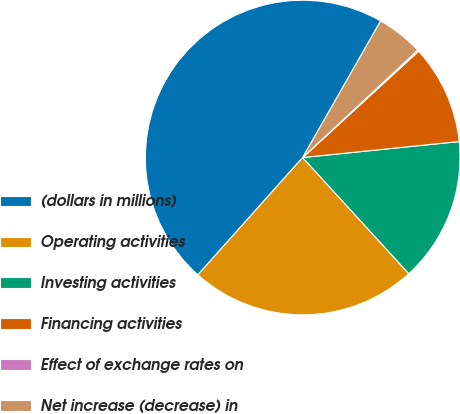Convert chart. <chart><loc_0><loc_0><loc_500><loc_500><pie_chart><fcel>(dollars in millions)<fcel>Operating activities<fcel>Investing activities<fcel>Financing activities<fcel>Effect of exchange rates on<fcel>Net increase (decrease) in<nl><fcel>46.65%<fcel>23.39%<fcel>14.84%<fcel>10.19%<fcel>0.14%<fcel>4.79%<nl></chart> 